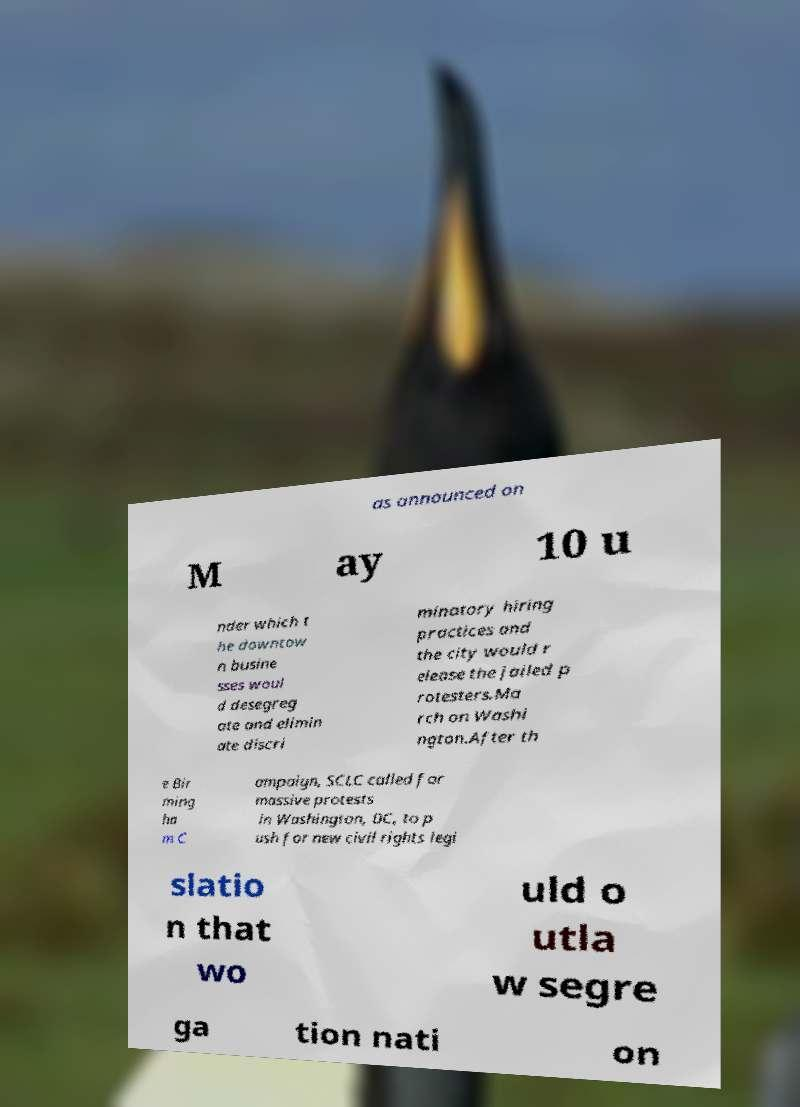What messages or text are displayed in this image? I need them in a readable, typed format. as announced on M ay 10 u nder which t he downtow n busine sses woul d desegreg ate and elimin ate discri minatory hiring practices and the city would r elease the jailed p rotesters.Ma rch on Washi ngton.After th e Bir ming ha m C ampaign, SCLC called for massive protests in Washington, DC, to p ush for new civil rights legi slatio n that wo uld o utla w segre ga tion nati on 